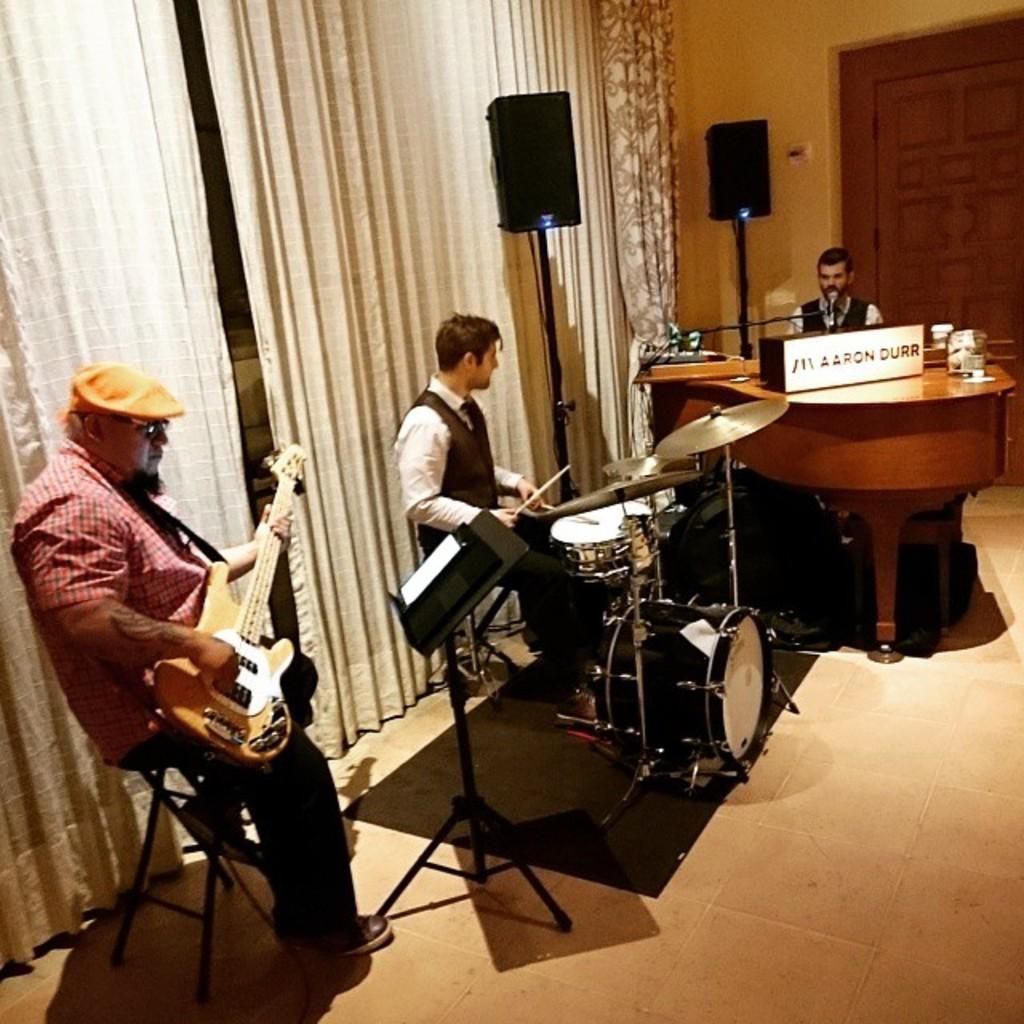Can you describe this image briefly? There are three people in image. In which one which one man is behind keyboard and second man is playing his musical instrument and third man is playing his guitar and he is also wearing a hat. We can also see speakers which are in black color, on right side we can see a door. In the background there are curtains which are in white color. 